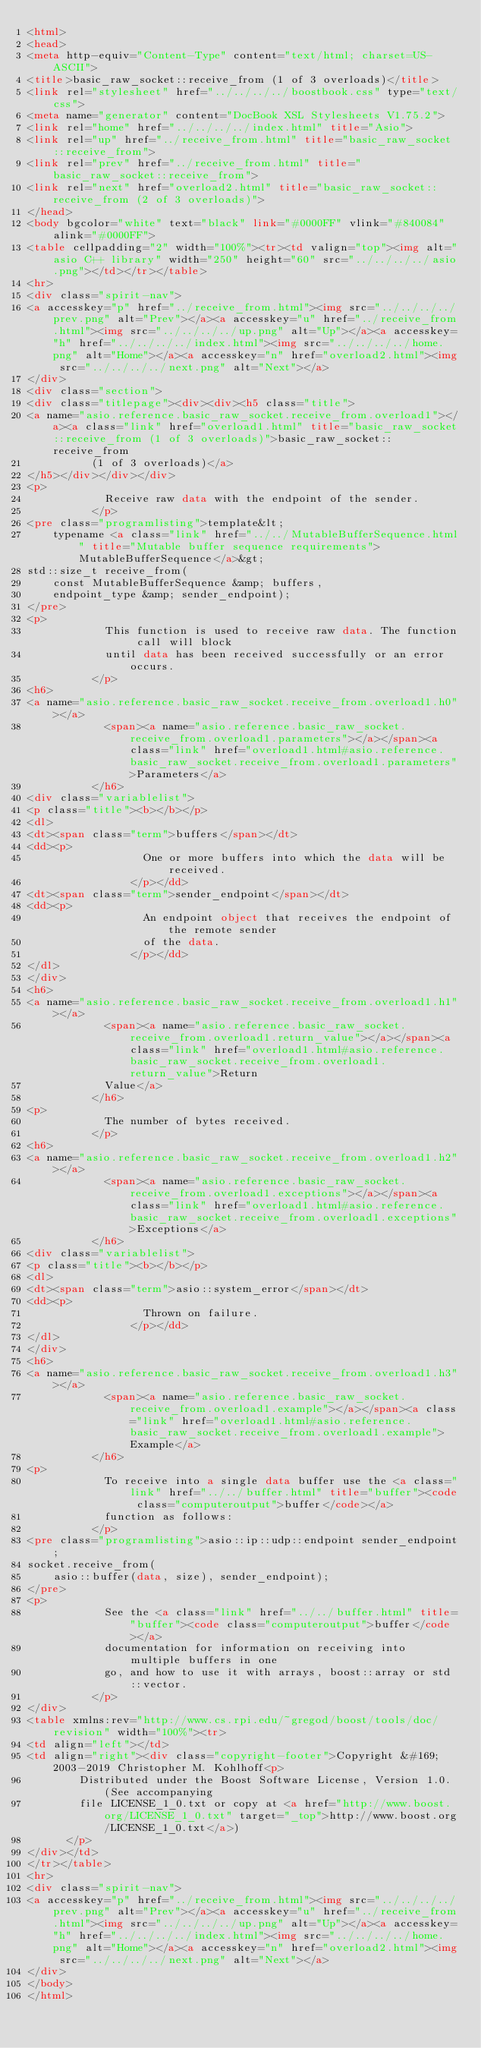Convert code to text. <code><loc_0><loc_0><loc_500><loc_500><_HTML_><html>
<head>
<meta http-equiv="Content-Type" content="text/html; charset=US-ASCII">
<title>basic_raw_socket::receive_from (1 of 3 overloads)</title>
<link rel="stylesheet" href="../../../../boostbook.css" type="text/css">
<meta name="generator" content="DocBook XSL Stylesheets V1.75.2">
<link rel="home" href="../../../../index.html" title="Asio">
<link rel="up" href="../receive_from.html" title="basic_raw_socket::receive_from">
<link rel="prev" href="../receive_from.html" title="basic_raw_socket::receive_from">
<link rel="next" href="overload2.html" title="basic_raw_socket::receive_from (2 of 3 overloads)">
</head>
<body bgcolor="white" text="black" link="#0000FF" vlink="#840084" alink="#0000FF">
<table cellpadding="2" width="100%"><tr><td valign="top"><img alt="asio C++ library" width="250" height="60" src="../../../../asio.png"></td></tr></table>
<hr>
<div class="spirit-nav">
<a accesskey="p" href="../receive_from.html"><img src="../../../../prev.png" alt="Prev"></a><a accesskey="u" href="../receive_from.html"><img src="../../../../up.png" alt="Up"></a><a accesskey="h" href="../../../../index.html"><img src="../../../../home.png" alt="Home"></a><a accesskey="n" href="overload2.html"><img src="../../../../next.png" alt="Next"></a>
</div>
<div class="section">
<div class="titlepage"><div><div><h5 class="title">
<a name="asio.reference.basic_raw_socket.receive_from.overload1"></a><a class="link" href="overload1.html" title="basic_raw_socket::receive_from (1 of 3 overloads)">basic_raw_socket::receive_from
          (1 of 3 overloads)</a>
</h5></div></div></div>
<p>
            Receive raw data with the endpoint of the sender.
          </p>
<pre class="programlisting">template&lt;
    typename <a class="link" href="../../MutableBufferSequence.html" title="Mutable buffer sequence requirements">MutableBufferSequence</a>&gt;
std::size_t receive_from(
    const MutableBufferSequence &amp; buffers,
    endpoint_type &amp; sender_endpoint);
</pre>
<p>
            This function is used to receive raw data. The function call will block
            until data has been received successfully or an error occurs.
          </p>
<h6>
<a name="asio.reference.basic_raw_socket.receive_from.overload1.h0"></a>
            <span><a name="asio.reference.basic_raw_socket.receive_from.overload1.parameters"></a></span><a class="link" href="overload1.html#asio.reference.basic_raw_socket.receive_from.overload1.parameters">Parameters</a>
          </h6>
<div class="variablelist">
<p class="title"><b></b></p>
<dl>
<dt><span class="term">buffers</span></dt>
<dd><p>
                  One or more buffers into which the data will be received.
                </p></dd>
<dt><span class="term">sender_endpoint</span></dt>
<dd><p>
                  An endpoint object that receives the endpoint of the remote sender
                  of the data.
                </p></dd>
</dl>
</div>
<h6>
<a name="asio.reference.basic_raw_socket.receive_from.overload1.h1"></a>
            <span><a name="asio.reference.basic_raw_socket.receive_from.overload1.return_value"></a></span><a class="link" href="overload1.html#asio.reference.basic_raw_socket.receive_from.overload1.return_value">Return
            Value</a>
          </h6>
<p>
            The number of bytes received.
          </p>
<h6>
<a name="asio.reference.basic_raw_socket.receive_from.overload1.h2"></a>
            <span><a name="asio.reference.basic_raw_socket.receive_from.overload1.exceptions"></a></span><a class="link" href="overload1.html#asio.reference.basic_raw_socket.receive_from.overload1.exceptions">Exceptions</a>
          </h6>
<div class="variablelist">
<p class="title"><b></b></p>
<dl>
<dt><span class="term">asio::system_error</span></dt>
<dd><p>
                  Thrown on failure.
                </p></dd>
</dl>
</div>
<h6>
<a name="asio.reference.basic_raw_socket.receive_from.overload1.h3"></a>
            <span><a name="asio.reference.basic_raw_socket.receive_from.overload1.example"></a></span><a class="link" href="overload1.html#asio.reference.basic_raw_socket.receive_from.overload1.example">Example</a>
          </h6>
<p>
            To receive into a single data buffer use the <a class="link" href="../../buffer.html" title="buffer"><code class="computeroutput">buffer</code></a>
            function as follows:
          </p>
<pre class="programlisting">asio::ip::udp::endpoint sender_endpoint;
socket.receive_from(
    asio::buffer(data, size), sender_endpoint);
</pre>
<p>
            See the <a class="link" href="../../buffer.html" title="buffer"><code class="computeroutput">buffer</code></a>
            documentation for information on receiving into multiple buffers in one
            go, and how to use it with arrays, boost::array or std::vector.
          </p>
</div>
<table xmlns:rev="http://www.cs.rpi.edu/~gregod/boost/tools/doc/revision" width="100%"><tr>
<td align="left"></td>
<td align="right"><div class="copyright-footer">Copyright &#169; 2003-2019 Christopher M. Kohlhoff<p>
        Distributed under the Boost Software License, Version 1.0. (See accompanying
        file LICENSE_1_0.txt or copy at <a href="http://www.boost.org/LICENSE_1_0.txt" target="_top">http://www.boost.org/LICENSE_1_0.txt</a>)
      </p>
</div></td>
</tr></table>
<hr>
<div class="spirit-nav">
<a accesskey="p" href="../receive_from.html"><img src="../../../../prev.png" alt="Prev"></a><a accesskey="u" href="../receive_from.html"><img src="../../../../up.png" alt="Up"></a><a accesskey="h" href="../../../../index.html"><img src="../../../../home.png" alt="Home"></a><a accesskey="n" href="overload2.html"><img src="../../../../next.png" alt="Next"></a>
</div>
</body>
</html>
</code> 